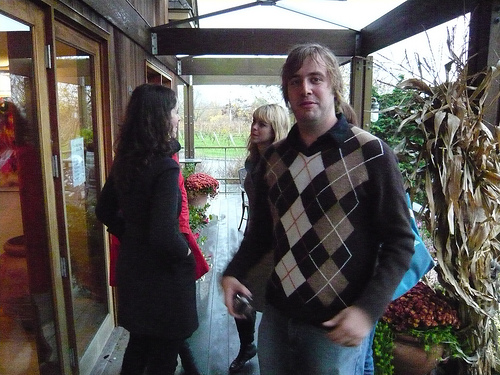<image>
Can you confirm if the cornstalk is above the mum? Yes. The cornstalk is positioned above the mum in the vertical space, higher up in the scene. 